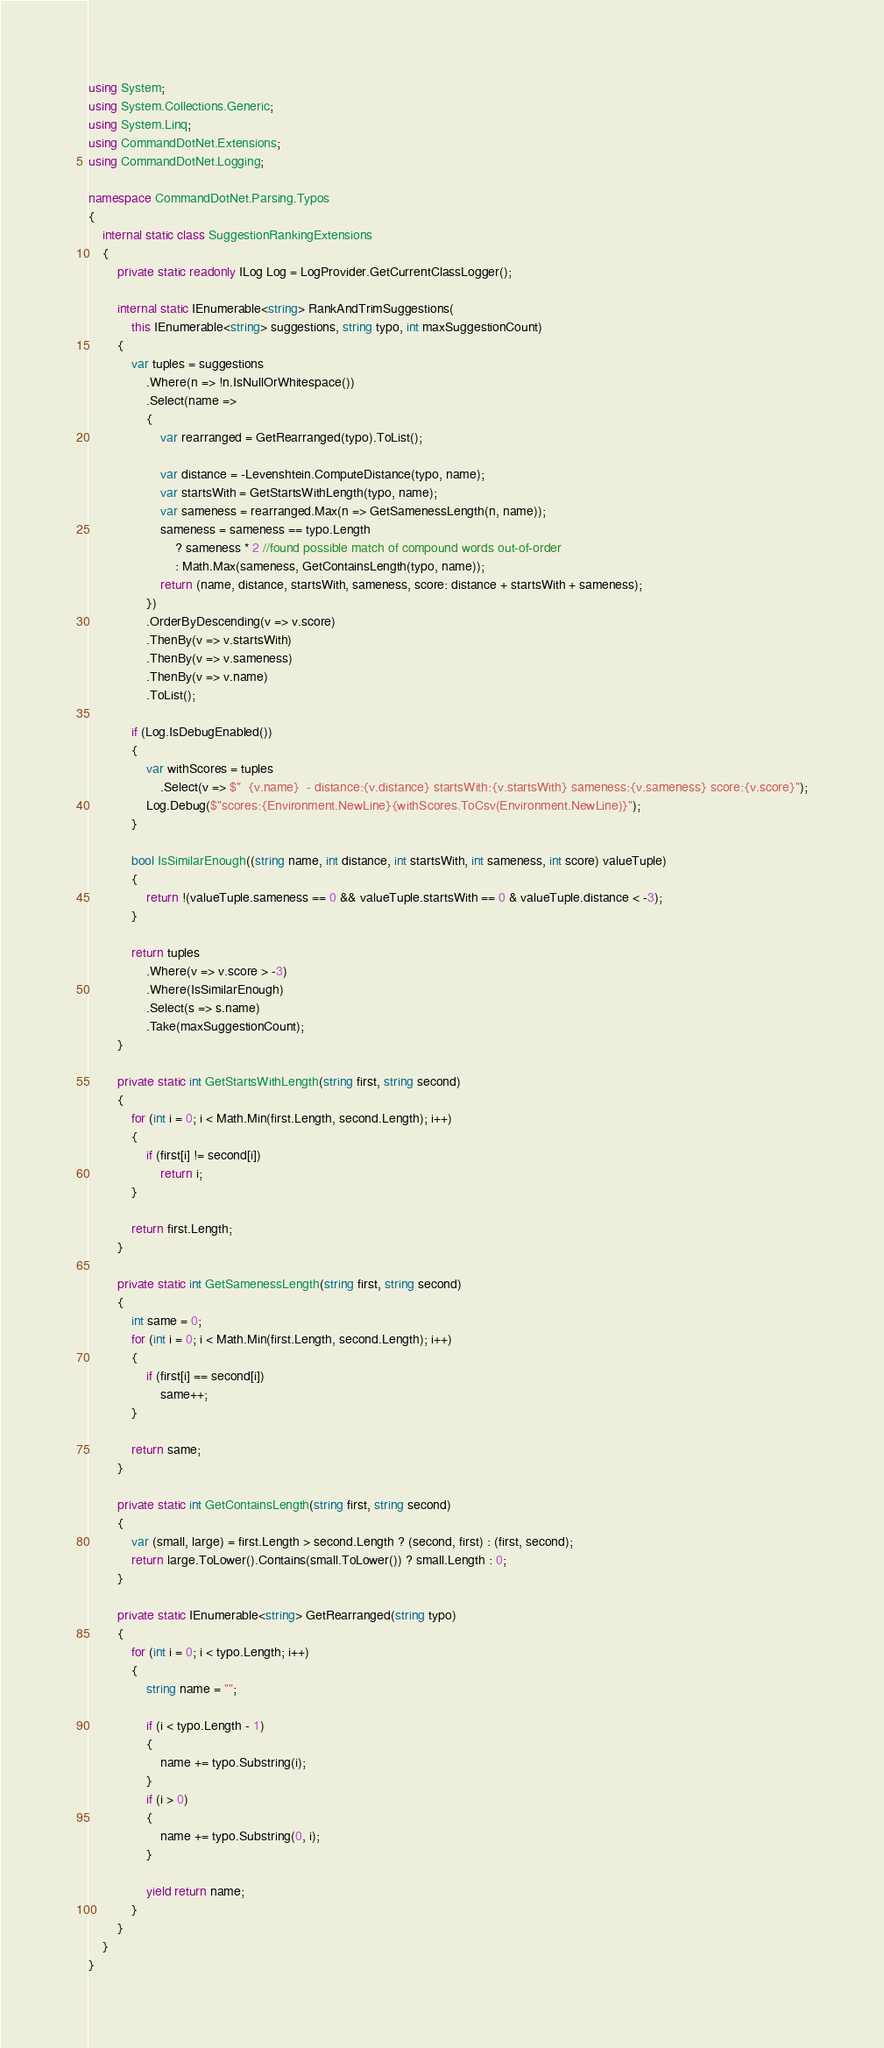<code> <loc_0><loc_0><loc_500><loc_500><_C#_>using System;
using System.Collections.Generic;
using System.Linq;
using CommandDotNet.Extensions;
using CommandDotNet.Logging;

namespace CommandDotNet.Parsing.Typos
{
    internal static class SuggestionRankingExtensions
    {
        private static readonly ILog Log = LogProvider.GetCurrentClassLogger();

        internal static IEnumerable<string> RankAndTrimSuggestions(
            this IEnumerable<string> suggestions, string typo, int maxSuggestionCount)
        {
            var tuples = suggestions
                .Where(n => !n.IsNullOrWhitespace())
                .Select(name =>
                {
                    var rearranged = GetRearranged(typo).ToList();

                    var distance = -Levenshtein.ComputeDistance(typo, name);
                    var startsWith = GetStartsWithLength(typo, name);
                    var sameness = rearranged.Max(n => GetSamenessLength(n, name));
                    sameness = sameness == typo.Length 
                        ? sameness * 2 //found possible match of compound words out-of-order
                        : Math.Max(sameness, GetContainsLength(typo, name));
                    return (name, distance, startsWith, sameness, score: distance + startsWith + sameness);
                })
                .OrderByDescending(v => v.score)
                .ThenBy(v => v.startsWith)
                .ThenBy(v => v.sameness)
                .ThenBy(v => v.name)
                .ToList();

            if (Log.IsDebugEnabled())
            {
                var withScores = tuples
                    .Select(v => $"  {v.name}  - distance:{v.distance} startsWith:{v.startsWith} sameness:{v.sameness} score:{v.score}");
                Log.Debug($"scores:{Environment.NewLine}{withScores.ToCsv(Environment.NewLine)}");
            }

            bool IsSimilarEnough((string name, int distance, int startsWith, int sameness, int score) valueTuple)
            {
                return !(valueTuple.sameness == 0 && valueTuple.startsWith == 0 & valueTuple.distance < -3);
            }

            return tuples
                .Where(v => v.score > -3)
                .Where(IsSimilarEnough)
                .Select(s => s.name)
                .Take(maxSuggestionCount);
        }

        private static int GetStartsWithLength(string first, string second)
        {
            for (int i = 0; i < Math.Min(first.Length, second.Length); i++)
            {
                if (first[i] != second[i])
                    return i;
            }

            return first.Length;
        }

        private static int GetSamenessLength(string first, string second)
        {
            int same = 0;
            for (int i = 0; i < Math.Min(first.Length, second.Length); i++)
            {
                if (first[i] == second[i])
                    same++;
            }

            return same;
        }

        private static int GetContainsLength(string first, string second)
        {
            var (small, large) = first.Length > second.Length ? (second, first) : (first, second);
            return large.ToLower().Contains(small.ToLower()) ? small.Length : 0;
        }

        private static IEnumerable<string> GetRearranged(string typo)
        {
            for (int i = 0; i < typo.Length; i++)
            {
                string name = "";

                if (i < typo.Length - 1)
                {
                    name += typo.Substring(i);
                }
                if (i > 0)
                {
                    name += typo.Substring(0, i);
                }

                yield return name;
            }
        }
    }
}</code> 